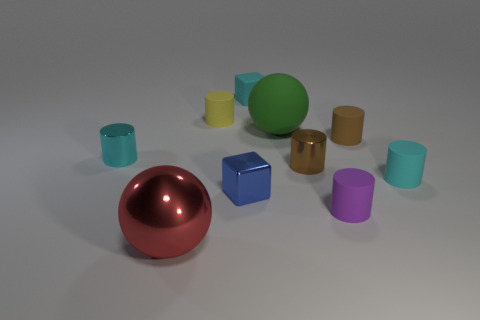Are there any other tiny purple matte things of the same shape as the purple object?
Your answer should be compact. No. Do the big object behind the red thing and the small cyan matte thing to the right of the tiny rubber cube have the same shape?
Offer a very short reply. No. What shape is the cyan object that is on the right side of the yellow thing and behind the small brown metallic cylinder?
Your response must be concise. Cube. Are there any purple cubes of the same size as the brown metallic object?
Provide a short and direct response. No. There is a large metallic object; is it the same color as the small object to the left of the red ball?
Provide a succinct answer. No. What is the material of the yellow object?
Your answer should be very brief. Rubber. What is the color of the ball that is in front of the cyan rubber cylinder?
Ensure brevity in your answer.  Red. What number of small matte objects are the same color as the tiny matte block?
Offer a terse response. 1. How many objects are both behind the brown shiny cylinder and to the left of the brown metallic cylinder?
Offer a very short reply. 4. What is the shape of the brown shiny object that is the same size as the brown rubber thing?
Provide a short and direct response. Cylinder. 